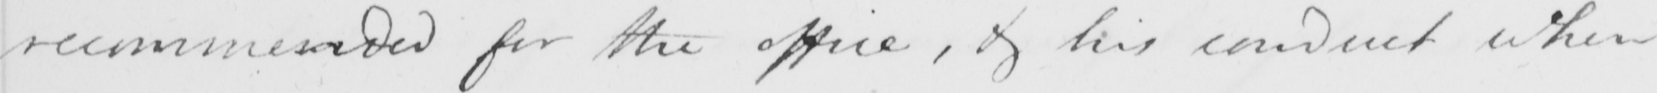Can you tell me what this handwritten text says? recommended for the office , & his conduct when 